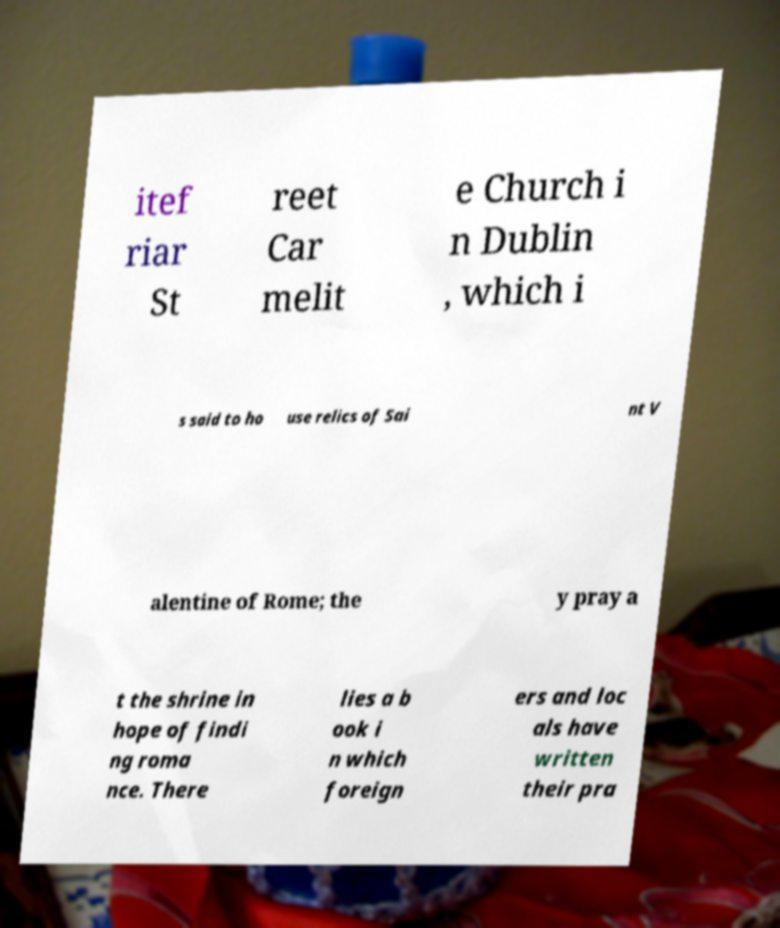What messages or text are displayed in this image? I need them in a readable, typed format. itef riar St reet Car melit e Church i n Dublin , which i s said to ho use relics of Sai nt V alentine of Rome; the y pray a t the shrine in hope of findi ng roma nce. There lies a b ook i n which foreign ers and loc als have written their pra 